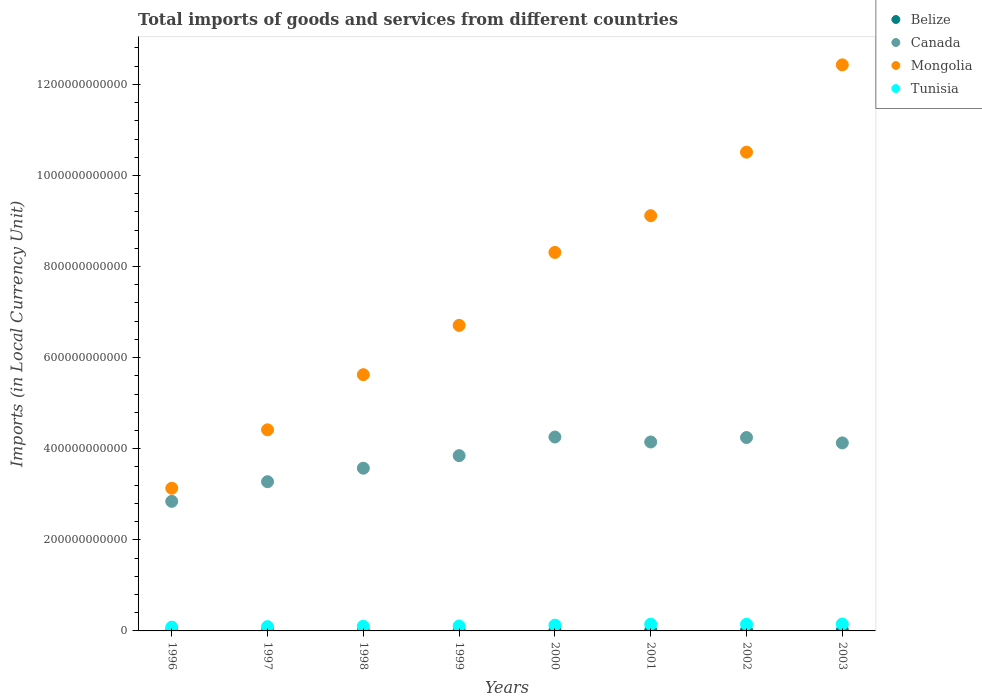Is the number of dotlines equal to the number of legend labels?
Ensure brevity in your answer.  Yes. What is the Amount of goods and services imports in Belize in 1999?
Provide a succinct answer. 9.87e+08. Across all years, what is the maximum Amount of goods and services imports in Mongolia?
Make the answer very short. 1.24e+12. Across all years, what is the minimum Amount of goods and services imports in Canada?
Provide a short and direct response. 2.84e+11. In which year was the Amount of goods and services imports in Tunisia minimum?
Your answer should be very brief. 1996. What is the total Amount of goods and services imports in Belize in the graph?
Give a very brief answer. 8.12e+09. What is the difference between the Amount of goods and services imports in Tunisia in 1999 and that in 2001?
Provide a short and direct response. -3.97e+09. What is the difference between the Amount of goods and services imports in Belize in 2003 and the Amount of goods and services imports in Canada in 1996?
Your response must be concise. -2.83e+11. What is the average Amount of goods and services imports in Belize per year?
Ensure brevity in your answer.  1.01e+09. In the year 2001, what is the difference between the Amount of goods and services imports in Mongolia and Amount of goods and services imports in Belize?
Make the answer very short. 9.10e+11. In how many years, is the Amount of goods and services imports in Tunisia greater than 320000000000 LCU?
Your answer should be very brief. 0. What is the ratio of the Amount of goods and services imports in Mongolia in 1998 to that in 2001?
Make the answer very short. 0.62. Is the Amount of goods and services imports in Belize in 1996 less than that in 1998?
Ensure brevity in your answer.  Yes. Is the difference between the Amount of goods and services imports in Mongolia in 2001 and 2002 greater than the difference between the Amount of goods and services imports in Belize in 2001 and 2002?
Offer a very short reply. No. What is the difference between the highest and the second highest Amount of goods and services imports in Mongolia?
Provide a succinct answer. 1.92e+11. What is the difference between the highest and the lowest Amount of goods and services imports in Belize?
Offer a terse response. 6.61e+08. In how many years, is the Amount of goods and services imports in Mongolia greater than the average Amount of goods and services imports in Mongolia taken over all years?
Offer a terse response. 4. Is it the case that in every year, the sum of the Amount of goods and services imports in Belize and Amount of goods and services imports in Mongolia  is greater than the Amount of goods and services imports in Tunisia?
Your response must be concise. Yes. Does the Amount of goods and services imports in Canada monotonically increase over the years?
Ensure brevity in your answer.  No. Is the Amount of goods and services imports in Tunisia strictly less than the Amount of goods and services imports in Canada over the years?
Provide a short and direct response. Yes. How many dotlines are there?
Your response must be concise. 4. How many years are there in the graph?
Give a very brief answer. 8. What is the difference between two consecutive major ticks on the Y-axis?
Make the answer very short. 2.00e+11. Does the graph contain grids?
Provide a short and direct response. No. How are the legend labels stacked?
Provide a short and direct response. Vertical. What is the title of the graph?
Provide a succinct answer. Total imports of goods and services from different countries. What is the label or title of the X-axis?
Offer a very short reply. Years. What is the label or title of the Y-axis?
Offer a very short reply. Imports (in Local Currency Unit). What is the Imports (in Local Currency Unit) in Belize in 1996?
Your answer should be compact. 6.45e+08. What is the Imports (in Local Currency Unit) of Canada in 1996?
Give a very brief answer. 2.84e+11. What is the Imports (in Local Currency Unit) in Mongolia in 1996?
Keep it short and to the point. 3.13e+11. What is the Imports (in Local Currency Unit) of Tunisia in 1996?
Make the answer very short. 8.32e+09. What is the Imports (in Local Currency Unit) of Belize in 1997?
Keep it short and to the point. 7.29e+08. What is the Imports (in Local Currency Unit) in Canada in 1997?
Provide a succinct answer. 3.28e+11. What is the Imports (in Local Currency Unit) in Mongolia in 1997?
Make the answer very short. 4.42e+11. What is the Imports (in Local Currency Unit) of Tunisia in 1997?
Your answer should be very brief. 9.50e+09. What is the Imports (in Local Currency Unit) in Belize in 1998?
Provide a short and direct response. 7.84e+08. What is the Imports (in Local Currency Unit) in Canada in 1998?
Provide a succinct answer. 3.57e+11. What is the Imports (in Local Currency Unit) in Mongolia in 1998?
Your response must be concise. 5.63e+11. What is the Imports (in Local Currency Unit) of Tunisia in 1998?
Make the answer very short. 1.03e+1. What is the Imports (in Local Currency Unit) in Belize in 1999?
Provide a short and direct response. 9.87e+08. What is the Imports (in Local Currency Unit) in Canada in 1999?
Your response must be concise. 3.85e+11. What is the Imports (in Local Currency Unit) of Mongolia in 1999?
Keep it short and to the point. 6.71e+11. What is the Imports (in Local Currency Unit) in Tunisia in 1999?
Make the answer very short. 1.09e+1. What is the Imports (in Local Currency Unit) in Belize in 2000?
Offer a terse response. 1.23e+09. What is the Imports (in Local Currency Unit) in Canada in 2000?
Make the answer very short. 4.26e+11. What is the Imports (in Local Currency Unit) in Mongolia in 2000?
Offer a very short reply. 8.31e+11. What is the Imports (in Local Currency Unit) of Tunisia in 2000?
Provide a succinct answer. 1.26e+1. What is the Imports (in Local Currency Unit) in Belize in 2001?
Keep it short and to the point. 1.20e+09. What is the Imports (in Local Currency Unit) of Canada in 2001?
Your answer should be very brief. 4.15e+11. What is the Imports (in Local Currency Unit) of Mongolia in 2001?
Offer a terse response. 9.12e+11. What is the Imports (in Local Currency Unit) in Tunisia in 2001?
Your answer should be very brief. 1.48e+1. What is the Imports (in Local Currency Unit) in Belize in 2002?
Provide a succinct answer. 1.23e+09. What is the Imports (in Local Currency Unit) of Canada in 2002?
Offer a very short reply. 4.25e+11. What is the Imports (in Local Currency Unit) of Mongolia in 2002?
Ensure brevity in your answer.  1.05e+12. What is the Imports (in Local Currency Unit) in Tunisia in 2002?
Offer a terse response. 1.47e+1. What is the Imports (in Local Currency Unit) in Belize in 2003?
Offer a terse response. 1.31e+09. What is the Imports (in Local Currency Unit) in Canada in 2003?
Give a very brief answer. 4.13e+11. What is the Imports (in Local Currency Unit) in Mongolia in 2003?
Your response must be concise. 1.24e+12. What is the Imports (in Local Currency Unit) in Tunisia in 2003?
Provide a short and direct response. 1.52e+1. Across all years, what is the maximum Imports (in Local Currency Unit) in Belize?
Provide a succinct answer. 1.31e+09. Across all years, what is the maximum Imports (in Local Currency Unit) in Canada?
Your answer should be compact. 4.26e+11. Across all years, what is the maximum Imports (in Local Currency Unit) in Mongolia?
Your answer should be very brief. 1.24e+12. Across all years, what is the maximum Imports (in Local Currency Unit) of Tunisia?
Give a very brief answer. 1.52e+1. Across all years, what is the minimum Imports (in Local Currency Unit) of Belize?
Ensure brevity in your answer.  6.45e+08. Across all years, what is the minimum Imports (in Local Currency Unit) in Canada?
Give a very brief answer. 2.84e+11. Across all years, what is the minimum Imports (in Local Currency Unit) in Mongolia?
Make the answer very short. 3.13e+11. Across all years, what is the minimum Imports (in Local Currency Unit) of Tunisia?
Offer a very short reply. 8.32e+09. What is the total Imports (in Local Currency Unit) of Belize in the graph?
Make the answer very short. 8.12e+09. What is the total Imports (in Local Currency Unit) of Canada in the graph?
Offer a terse response. 3.03e+12. What is the total Imports (in Local Currency Unit) of Mongolia in the graph?
Your response must be concise. 6.02e+12. What is the total Imports (in Local Currency Unit) of Tunisia in the graph?
Make the answer very short. 9.63e+1. What is the difference between the Imports (in Local Currency Unit) in Belize in 1996 and that in 1997?
Make the answer very short. -8.42e+07. What is the difference between the Imports (in Local Currency Unit) in Canada in 1996 and that in 1997?
Keep it short and to the point. -4.31e+1. What is the difference between the Imports (in Local Currency Unit) of Mongolia in 1996 and that in 1997?
Give a very brief answer. -1.28e+11. What is the difference between the Imports (in Local Currency Unit) of Tunisia in 1996 and that in 1997?
Provide a short and direct response. -1.18e+09. What is the difference between the Imports (in Local Currency Unit) of Belize in 1996 and that in 1998?
Keep it short and to the point. -1.40e+08. What is the difference between the Imports (in Local Currency Unit) of Canada in 1996 and that in 1998?
Make the answer very short. -7.28e+1. What is the difference between the Imports (in Local Currency Unit) of Mongolia in 1996 and that in 1998?
Give a very brief answer. -2.49e+11. What is the difference between the Imports (in Local Currency Unit) in Tunisia in 1996 and that in 1998?
Your answer should be very brief. -1.98e+09. What is the difference between the Imports (in Local Currency Unit) in Belize in 1996 and that in 1999?
Give a very brief answer. -3.42e+08. What is the difference between the Imports (in Local Currency Unit) of Canada in 1996 and that in 1999?
Your response must be concise. -1.00e+11. What is the difference between the Imports (in Local Currency Unit) of Mongolia in 1996 and that in 1999?
Offer a terse response. -3.58e+11. What is the difference between the Imports (in Local Currency Unit) of Tunisia in 1996 and that in 1999?
Keep it short and to the point. -2.55e+09. What is the difference between the Imports (in Local Currency Unit) of Belize in 1996 and that in 2000?
Give a very brief answer. -5.81e+08. What is the difference between the Imports (in Local Currency Unit) in Canada in 1996 and that in 2000?
Give a very brief answer. -1.41e+11. What is the difference between the Imports (in Local Currency Unit) in Mongolia in 1996 and that in 2000?
Make the answer very short. -5.18e+11. What is the difference between the Imports (in Local Currency Unit) in Tunisia in 1996 and that in 2000?
Your answer should be compact. -4.31e+09. What is the difference between the Imports (in Local Currency Unit) in Belize in 1996 and that in 2001?
Your response must be concise. -5.60e+08. What is the difference between the Imports (in Local Currency Unit) in Canada in 1996 and that in 2001?
Provide a succinct answer. -1.30e+11. What is the difference between the Imports (in Local Currency Unit) in Mongolia in 1996 and that in 2001?
Offer a terse response. -5.98e+11. What is the difference between the Imports (in Local Currency Unit) in Tunisia in 1996 and that in 2001?
Ensure brevity in your answer.  -6.52e+09. What is the difference between the Imports (in Local Currency Unit) in Belize in 1996 and that in 2002?
Make the answer very short. -5.89e+08. What is the difference between the Imports (in Local Currency Unit) in Canada in 1996 and that in 2002?
Give a very brief answer. -1.40e+11. What is the difference between the Imports (in Local Currency Unit) in Mongolia in 1996 and that in 2002?
Provide a short and direct response. -7.38e+11. What is the difference between the Imports (in Local Currency Unit) in Tunisia in 1996 and that in 2002?
Your response must be concise. -6.34e+09. What is the difference between the Imports (in Local Currency Unit) in Belize in 1996 and that in 2003?
Make the answer very short. -6.61e+08. What is the difference between the Imports (in Local Currency Unit) of Canada in 1996 and that in 2003?
Offer a terse response. -1.28e+11. What is the difference between the Imports (in Local Currency Unit) in Mongolia in 1996 and that in 2003?
Keep it short and to the point. -9.30e+11. What is the difference between the Imports (in Local Currency Unit) in Tunisia in 1996 and that in 2003?
Your answer should be compact. -6.86e+09. What is the difference between the Imports (in Local Currency Unit) of Belize in 1997 and that in 1998?
Offer a terse response. -5.55e+07. What is the difference between the Imports (in Local Currency Unit) of Canada in 1997 and that in 1998?
Make the answer very short. -2.96e+1. What is the difference between the Imports (in Local Currency Unit) in Mongolia in 1997 and that in 1998?
Give a very brief answer. -1.21e+11. What is the difference between the Imports (in Local Currency Unit) of Tunisia in 1997 and that in 1998?
Offer a terse response. -7.98e+08. What is the difference between the Imports (in Local Currency Unit) in Belize in 1997 and that in 1999?
Offer a terse response. -2.58e+08. What is the difference between the Imports (in Local Currency Unit) in Canada in 1997 and that in 1999?
Provide a succinct answer. -5.73e+1. What is the difference between the Imports (in Local Currency Unit) in Mongolia in 1997 and that in 1999?
Your response must be concise. -2.29e+11. What is the difference between the Imports (in Local Currency Unit) of Tunisia in 1997 and that in 1999?
Make the answer very short. -1.37e+09. What is the difference between the Imports (in Local Currency Unit) of Belize in 1997 and that in 2000?
Offer a terse response. -4.97e+08. What is the difference between the Imports (in Local Currency Unit) of Canada in 1997 and that in 2000?
Provide a short and direct response. -9.82e+1. What is the difference between the Imports (in Local Currency Unit) of Mongolia in 1997 and that in 2000?
Keep it short and to the point. -3.90e+11. What is the difference between the Imports (in Local Currency Unit) of Tunisia in 1997 and that in 2000?
Your answer should be compact. -3.13e+09. What is the difference between the Imports (in Local Currency Unit) in Belize in 1997 and that in 2001?
Your response must be concise. -4.76e+08. What is the difference between the Imports (in Local Currency Unit) in Canada in 1997 and that in 2001?
Offer a very short reply. -8.72e+1. What is the difference between the Imports (in Local Currency Unit) of Mongolia in 1997 and that in 2001?
Ensure brevity in your answer.  -4.70e+11. What is the difference between the Imports (in Local Currency Unit) in Tunisia in 1997 and that in 2001?
Your answer should be compact. -5.34e+09. What is the difference between the Imports (in Local Currency Unit) of Belize in 1997 and that in 2002?
Make the answer very short. -5.04e+08. What is the difference between the Imports (in Local Currency Unit) in Canada in 1997 and that in 2002?
Ensure brevity in your answer.  -9.70e+1. What is the difference between the Imports (in Local Currency Unit) of Mongolia in 1997 and that in 2002?
Ensure brevity in your answer.  -6.10e+11. What is the difference between the Imports (in Local Currency Unit) in Tunisia in 1997 and that in 2002?
Provide a short and direct response. -5.16e+09. What is the difference between the Imports (in Local Currency Unit) of Belize in 1997 and that in 2003?
Your response must be concise. -5.77e+08. What is the difference between the Imports (in Local Currency Unit) of Canada in 1997 and that in 2003?
Make the answer very short. -8.52e+1. What is the difference between the Imports (in Local Currency Unit) of Mongolia in 1997 and that in 2003?
Offer a very short reply. -8.01e+11. What is the difference between the Imports (in Local Currency Unit) of Tunisia in 1997 and that in 2003?
Make the answer very short. -5.68e+09. What is the difference between the Imports (in Local Currency Unit) in Belize in 1998 and that in 1999?
Offer a terse response. -2.03e+08. What is the difference between the Imports (in Local Currency Unit) in Canada in 1998 and that in 1999?
Offer a very short reply. -2.76e+1. What is the difference between the Imports (in Local Currency Unit) of Mongolia in 1998 and that in 1999?
Provide a succinct answer. -1.08e+11. What is the difference between the Imports (in Local Currency Unit) of Tunisia in 1998 and that in 1999?
Ensure brevity in your answer.  -5.73e+08. What is the difference between the Imports (in Local Currency Unit) of Belize in 1998 and that in 2000?
Provide a succinct answer. -4.42e+08. What is the difference between the Imports (in Local Currency Unit) of Canada in 1998 and that in 2000?
Ensure brevity in your answer.  -6.85e+1. What is the difference between the Imports (in Local Currency Unit) of Mongolia in 1998 and that in 2000?
Ensure brevity in your answer.  -2.68e+11. What is the difference between the Imports (in Local Currency Unit) in Tunisia in 1998 and that in 2000?
Your answer should be very brief. -2.34e+09. What is the difference between the Imports (in Local Currency Unit) of Belize in 1998 and that in 2001?
Your answer should be very brief. -4.20e+08. What is the difference between the Imports (in Local Currency Unit) of Canada in 1998 and that in 2001?
Your response must be concise. -5.76e+1. What is the difference between the Imports (in Local Currency Unit) of Mongolia in 1998 and that in 2001?
Offer a very short reply. -3.49e+11. What is the difference between the Imports (in Local Currency Unit) in Tunisia in 1998 and that in 2001?
Provide a short and direct response. -4.54e+09. What is the difference between the Imports (in Local Currency Unit) in Belize in 1998 and that in 2002?
Provide a short and direct response. -4.49e+08. What is the difference between the Imports (in Local Currency Unit) in Canada in 1998 and that in 2002?
Offer a terse response. -6.74e+1. What is the difference between the Imports (in Local Currency Unit) of Mongolia in 1998 and that in 2002?
Keep it short and to the point. -4.89e+11. What is the difference between the Imports (in Local Currency Unit) of Tunisia in 1998 and that in 2002?
Your response must be concise. -4.37e+09. What is the difference between the Imports (in Local Currency Unit) in Belize in 1998 and that in 2003?
Keep it short and to the point. -5.22e+08. What is the difference between the Imports (in Local Currency Unit) in Canada in 1998 and that in 2003?
Offer a very short reply. -5.56e+1. What is the difference between the Imports (in Local Currency Unit) of Mongolia in 1998 and that in 2003?
Keep it short and to the point. -6.80e+11. What is the difference between the Imports (in Local Currency Unit) of Tunisia in 1998 and that in 2003?
Offer a very short reply. -4.88e+09. What is the difference between the Imports (in Local Currency Unit) in Belize in 1999 and that in 2000?
Ensure brevity in your answer.  -2.39e+08. What is the difference between the Imports (in Local Currency Unit) of Canada in 1999 and that in 2000?
Your response must be concise. -4.09e+1. What is the difference between the Imports (in Local Currency Unit) in Mongolia in 1999 and that in 2000?
Your response must be concise. -1.60e+11. What is the difference between the Imports (in Local Currency Unit) of Tunisia in 1999 and that in 2000?
Keep it short and to the point. -1.76e+09. What is the difference between the Imports (in Local Currency Unit) of Belize in 1999 and that in 2001?
Offer a very short reply. -2.18e+08. What is the difference between the Imports (in Local Currency Unit) in Canada in 1999 and that in 2001?
Provide a succinct answer. -2.99e+1. What is the difference between the Imports (in Local Currency Unit) in Mongolia in 1999 and that in 2001?
Make the answer very short. -2.41e+11. What is the difference between the Imports (in Local Currency Unit) in Tunisia in 1999 and that in 2001?
Provide a succinct answer. -3.97e+09. What is the difference between the Imports (in Local Currency Unit) in Belize in 1999 and that in 2002?
Keep it short and to the point. -2.46e+08. What is the difference between the Imports (in Local Currency Unit) in Canada in 1999 and that in 2002?
Your response must be concise. -3.97e+1. What is the difference between the Imports (in Local Currency Unit) in Mongolia in 1999 and that in 2002?
Your answer should be compact. -3.80e+11. What is the difference between the Imports (in Local Currency Unit) in Tunisia in 1999 and that in 2002?
Keep it short and to the point. -3.79e+09. What is the difference between the Imports (in Local Currency Unit) in Belize in 1999 and that in 2003?
Your response must be concise. -3.19e+08. What is the difference between the Imports (in Local Currency Unit) of Canada in 1999 and that in 2003?
Make the answer very short. -2.79e+1. What is the difference between the Imports (in Local Currency Unit) in Mongolia in 1999 and that in 2003?
Your response must be concise. -5.72e+11. What is the difference between the Imports (in Local Currency Unit) in Tunisia in 1999 and that in 2003?
Give a very brief answer. -4.31e+09. What is the difference between the Imports (in Local Currency Unit) of Belize in 2000 and that in 2001?
Offer a very short reply. 2.11e+07. What is the difference between the Imports (in Local Currency Unit) in Canada in 2000 and that in 2001?
Offer a terse response. 1.09e+1. What is the difference between the Imports (in Local Currency Unit) of Mongolia in 2000 and that in 2001?
Your response must be concise. -8.07e+1. What is the difference between the Imports (in Local Currency Unit) of Tunisia in 2000 and that in 2001?
Ensure brevity in your answer.  -2.21e+09. What is the difference between the Imports (in Local Currency Unit) in Belize in 2000 and that in 2002?
Give a very brief answer. -7.40e+06. What is the difference between the Imports (in Local Currency Unit) in Canada in 2000 and that in 2002?
Provide a succinct answer. 1.13e+09. What is the difference between the Imports (in Local Currency Unit) in Mongolia in 2000 and that in 2002?
Provide a succinct answer. -2.20e+11. What is the difference between the Imports (in Local Currency Unit) of Tunisia in 2000 and that in 2002?
Give a very brief answer. -2.03e+09. What is the difference between the Imports (in Local Currency Unit) in Belize in 2000 and that in 2003?
Give a very brief answer. -8.00e+07. What is the difference between the Imports (in Local Currency Unit) of Canada in 2000 and that in 2003?
Provide a short and direct response. 1.29e+1. What is the difference between the Imports (in Local Currency Unit) in Mongolia in 2000 and that in 2003?
Keep it short and to the point. -4.12e+11. What is the difference between the Imports (in Local Currency Unit) of Tunisia in 2000 and that in 2003?
Provide a succinct answer. -2.55e+09. What is the difference between the Imports (in Local Currency Unit) of Belize in 2001 and that in 2002?
Provide a short and direct response. -2.85e+07. What is the difference between the Imports (in Local Currency Unit) in Canada in 2001 and that in 2002?
Your response must be concise. -9.81e+09. What is the difference between the Imports (in Local Currency Unit) of Mongolia in 2001 and that in 2002?
Provide a succinct answer. -1.39e+11. What is the difference between the Imports (in Local Currency Unit) in Tunisia in 2001 and that in 2002?
Give a very brief answer. 1.77e+08. What is the difference between the Imports (in Local Currency Unit) in Belize in 2001 and that in 2003?
Provide a succinct answer. -1.01e+08. What is the difference between the Imports (in Local Currency Unit) of Canada in 2001 and that in 2003?
Give a very brief answer. 2.00e+09. What is the difference between the Imports (in Local Currency Unit) of Mongolia in 2001 and that in 2003?
Provide a short and direct response. -3.31e+11. What is the difference between the Imports (in Local Currency Unit) in Tunisia in 2001 and that in 2003?
Give a very brief answer. -3.41e+08. What is the difference between the Imports (in Local Currency Unit) in Belize in 2002 and that in 2003?
Offer a terse response. -7.26e+07. What is the difference between the Imports (in Local Currency Unit) in Canada in 2002 and that in 2003?
Your response must be concise. 1.18e+1. What is the difference between the Imports (in Local Currency Unit) of Mongolia in 2002 and that in 2003?
Offer a very short reply. -1.92e+11. What is the difference between the Imports (in Local Currency Unit) in Tunisia in 2002 and that in 2003?
Offer a terse response. -5.18e+08. What is the difference between the Imports (in Local Currency Unit) in Belize in 1996 and the Imports (in Local Currency Unit) in Canada in 1997?
Offer a terse response. -3.27e+11. What is the difference between the Imports (in Local Currency Unit) in Belize in 1996 and the Imports (in Local Currency Unit) in Mongolia in 1997?
Make the answer very short. -4.41e+11. What is the difference between the Imports (in Local Currency Unit) of Belize in 1996 and the Imports (in Local Currency Unit) of Tunisia in 1997?
Ensure brevity in your answer.  -8.85e+09. What is the difference between the Imports (in Local Currency Unit) in Canada in 1996 and the Imports (in Local Currency Unit) in Mongolia in 1997?
Your answer should be compact. -1.57e+11. What is the difference between the Imports (in Local Currency Unit) in Canada in 1996 and the Imports (in Local Currency Unit) in Tunisia in 1997?
Your answer should be very brief. 2.75e+11. What is the difference between the Imports (in Local Currency Unit) in Mongolia in 1996 and the Imports (in Local Currency Unit) in Tunisia in 1997?
Ensure brevity in your answer.  3.04e+11. What is the difference between the Imports (in Local Currency Unit) in Belize in 1996 and the Imports (in Local Currency Unit) in Canada in 1998?
Your answer should be very brief. -3.57e+11. What is the difference between the Imports (in Local Currency Unit) in Belize in 1996 and the Imports (in Local Currency Unit) in Mongolia in 1998?
Ensure brevity in your answer.  -5.62e+11. What is the difference between the Imports (in Local Currency Unit) of Belize in 1996 and the Imports (in Local Currency Unit) of Tunisia in 1998?
Provide a succinct answer. -9.65e+09. What is the difference between the Imports (in Local Currency Unit) of Canada in 1996 and the Imports (in Local Currency Unit) of Mongolia in 1998?
Your answer should be very brief. -2.78e+11. What is the difference between the Imports (in Local Currency Unit) in Canada in 1996 and the Imports (in Local Currency Unit) in Tunisia in 1998?
Your answer should be compact. 2.74e+11. What is the difference between the Imports (in Local Currency Unit) of Mongolia in 1996 and the Imports (in Local Currency Unit) of Tunisia in 1998?
Provide a short and direct response. 3.03e+11. What is the difference between the Imports (in Local Currency Unit) of Belize in 1996 and the Imports (in Local Currency Unit) of Canada in 1999?
Offer a terse response. -3.84e+11. What is the difference between the Imports (in Local Currency Unit) of Belize in 1996 and the Imports (in Local Currency Unit) of Mongolia in 1999?
Provide a short and direct response. -6.70e+11. What is the difference between the Imports (in Local Currency Unit) of Belize in 1996 and the Imports (in Local Currency Unit) of Tunisia in 1999?
Your answer should be very brief. -1.02e+1. What is the difference between the Imports (in Local Currency Unit) of Canada in 1996 and the Imports (in Local Currency Unit) of Mongolia in 1999?
Make the answer very short. -3.86e+11. What is the difference between the Imports (in Local Currency Unit) of Canada in 1996 and the Imports (in Local Currency Unit) of Tunisia in 1999?
Your response must be concise. 2.74e+11. What is the difference between the Imports (in Local Currency Unit) in Mongolia in 1996 and the Imports (in Local Currency Unit) in Tunisia in 1999?
Provide a succinct answer. 3.02e+11. What is the difference between the Imports (in Local Currency Unit) of Belize in 1996 and the Imports (in Local Currency Unit) of Canada in 2000?
Give a very brief answer. -4.25e+11. What is the difference between the Imports (in Local Currency Unit) of Belize in 1996 and the Imports (in Local Currency Unit) of Mongolia in 2000?
Make the answer very short. -8.30e+11. What is the difference between the Imports (in Local Currency Unit) of Belize in 1996 and the Imports (in Local Currency Unit) of Tunisia in 2000?
Your answer should be compact. -1.20e+1. What is the difference between the Imports (in Local Currency Unit) in Canada in 1996 and the Imports (in Local Currency Unit) in Mongolia in 2000?
Your answer should be very brief. -5.47e+11. What is the difference between the Imports (in Local Currency Unit) in Canada in 1996 and the Imports (in Local Currency Unit) in Tunisia in 2000?
Provide a succinct answer. 2.72e+11. What is the difference between the Imports (in Local Currency Unit) in Mongolia in 1996 and the Imports (in Local Currency Unit) in Tunisia in 2000?
Make the answer very short. 3.01e+11. What is the difference between the Imports (in Local Currency Unit) in Belize in 1996 and the Imports (in Local Currency Unit) in Canada in 2001?
Make the answer very short. -4.14e+11. What is the difference between the Imports (in Local Currency Unit) of Belize in 1996 and the Imports (in Local Currency Unit) of Mongolia in 2001?
Offer a terse response. -9.11e+11. What is the difference between the Imports (in Local Currency Unit) of Belize in 1996 and the Imports (in Local Currency Unit) of Tunisia in 2001?
Your answer should be compact. -1.42e+1. What is the difference between the Imports (in Local Currency Unit) of Canada in 1996 and the Imports (in Local Currency Unit) of Mongolia in 2001?
Keep it short and to the point. -6.27e+11. What is the difference between the Imports (in Local Currency Unit) of Canada in 1996 and the Imports (in Local Currency Unit) of Tunisia in 2001?
Your response must be concise. 2.70e+11. What is the difference between the Imports (in Local Currency Unit) in Mongolia in 1996 and the Imports (in Local Currency Unit) in Tunisia in 2001?
Provide a succinct answer. 2.98e+11. What is the difference between the Imports (in Local Currency Unit) of Belize in 1996 and the Imports (in Local Currency Unit) of Canada in 2002?
Keep it short and to the point. -4.24e+11. What is the difference between the Imports (in Local Currency Unit) in Belize in 1996 and the Imports (in Local Currency Unit) in Mongolia in 2002?
Your response must be concise. -1.05e+12. What is the difference between the Imports (in Local Currency Unit) in Belize in 1996 and the Imports (in Local Currency Unit) in Tunisia in 2002?
Keep it short and to the point. -1.40e+1. What is the difference between the Imports (in Local Currency Unit) in Canada in 1996 and the Imports (in Local Currency Unit) in Mongolia in 2002?
Your answer should be compact. -7.67e+11. What is the difference between the Imports (in Local Currency Unit) of Canada in 1996 and the Imports (in Local Currency Unit) of Tunisia in 2002?
Make the answer very short. 2.70e+11. What is the difference between the Imports (in Local Currency Unit) of Mongolia in 1996 and the Imports (in Local Currency Unit) of Tunisia in 2002?
Your answer should be compact. 2.99e+11. What is the difference between the Imports (in Local Currency Unit) of Belize in 1996 and the Imports (in Local Currency Unit) of Canada in 2003?
Your answer should be very brief. -4.12e+11. What is the difference between the Imports (in Local Currency Unit) of Belize in 1996 and the Imports (in Local Currency Unit) of Mongolia in 2003?
Provide a succinct answer. -1.24e+12. What is the difference between the Imports (in Local Currency Unit) of Belize in 1996 and the Imports (in Local Currency Unit) of Tunisia in 2003?
Your response must be concise. -1.45e+1. What is the difference between the Imports (in Local Currency Unit) of Canada in 1996 and the Imports (in Local Currency Unit) of Mongolia in 2003?
Your response must be concise. -9.58e+11. What is the difference between the Imports (in Local Currency Unit) in Canada in 1996 and the Imports (in Local Currency Unit) in Tunisia in 2003?
Give a very brief answer. 2.69e+11. What is the difference between the Imports (in Local Currency Unit) in Mongolia in 1996 and the Imports (in Local Currency Unit) in Tunisia in 2003?
Offer a terse response. 2.98e+11. What is the difference between the Imports (in Local Currency Unit) of Belize in 1997 and the Imports (in Local Currency Unit) of Canada in 1998?
Make the answer very short. -3.57e+11. What is the difference between the Imports (in Local Currency Unit) of Belize in 1997 and the Imports (in Local Currency Unit) of Mongolia in 1998?
Make the answer very short. -5.62e+11. What is the difference between the Imports (in Local Currency Unit) in Belize in 1997 and the Imports (in Local Currency Unit) in Tunisia in 1998?
Provide a short and direct response. -9.56e+09. What is the difference between the Imports (in Local Currency Unit) of Canada in 1997 and the Imports (in Local Currency Unit) of Mongolia in 1998?
Provide a succinct answer. -2.35e+11. What is the difference between the Imports (in Local Currency Unit) in Canada in 1997 and the Imports (in Local Currency Unit) in Tunisia in 1998?
Your response must be concise. 3.17e+11. What is the difference between the Imports (in Local Currency Unit) in Mongolia in 1997 and the Imports (in Local Currency Unit) in Tunisia in 1998?
Your response must be concise. 4.31e+11. What is the difference between the Imports (in Local Currency Unit) of Belize in 1997 and the Imports (in Local Currency Unit) of Canada in 1999?
Your response must be concise. -3.84e+11. What is the difference between the Imports (in Local Currency Unit) in Belize in 1997 and the Imports (in Local Currency Unit) in Mongolia in 1999?
Provide a succinct answer. -6.70e+11. What is the difference between the Imports (in Local Currency Unit) of Belize in 1997 and the Imports (in Local Currency Unit) of Tunisia in 1999?
Offer a very short reply. -1.01e+1. What is the difference between the Imports (in Local Currency Unit) in Canada in 1997 and the Imports (in Local Currency Unit) in Mongolia in 1999?
Provide a short and direct response. -3.43e+11. What is the difference between the Imports (in Local Currency Unit) in Canada in 1997 and the Imports (in Local Currency Unit) in Tunisia in 1999?
Your answer should be compact. 3.17e+11. What is the difference between the Imports (in Local Currency Unit) in Mongolia in 1997 and the Imports (in Local Currency Unit) in Tunisia in 1999?
Provide a succinct answer. 4.31e+11. What is the difference between the Imports (in Local Currency Unit) of Belize in 1997 and the Imports (in Local Currency Unit) of Canada in 2000?
Provide a succinct answer. -4.25e+11. What is the difference between the Imports (in Local Currency Unit) in Belize in 1997 and the Imports (in Local Currency Unit) in Mongolia in 2000?
Keep it short and to the point. -8.30e+11. What is the difference between the Imports (in Local Currency Unit) of Belize in 1997 and the Imports (in Local Currency Unit) of Tunisia in 2000?
Ensure brevity in your answer.  -1.19e+1. What is the difference between the Imports (in Local Currency Unit) in Canada in 1997 and the Imports (in Local Currency Unit) in Mongolia in 2000?
Provide a succinct answer. -5.03e+11. What is the difference between the Imports (in Local Currency Unit) of Canada in 1997 and the Imports (in Local Currency Unit) of Tunisia in 2000?
Ensure brevity in your answer.  3.15e+11. What is the difference between the Imports (in Local Currency Unit) in Mongolia in 1997 and the Imports (in Local Currency Unit) in Tunisia in 2000?
Your answer should be very brief. 4.29e+11. What is the difference between the Imports (in Local Currency Unit) of Belize in 1997 and the Imports (in Local Currency Unit) of Canada in 2001?
Your answer should be very brief. -4.14e+11. What is the difference between the Imports (in Local Currency Unit) of Belize in 1997 and the Imports (in Local Currency Unit) of Mongolia in 2001?
Offer a very short reply. -9.11e+11. What is the difference between the Imports (in Local Currency Unit) in Belize in 1997 and the Imports (in Local Currency Unit) in Tunisia in 2001?
Your answer should be very brief. -1.41e+1. What is the difference between the Imports (in Local Currency Unit) of Canada in 1997 and the Imports (in Local Currency Unit) of Mongolia in 2001?
Your answer should be very brief. -5.84e+11. What is the difference between the Imports (in Local Currency Unit) of Canada in 1997 and the Imports (in Local Currency Unit) of Tunisia in 2001?
Provide a succinct answer. 3.13e+11. What is the difference between the Imports (in Local Currency Unit) in Mongolia in 1997 and the Imports (in Local Currency Unit) in Tunisia in 2001?
Give a very brief answer. 4.27e+11. What is the difference between the Imports (in Local Currency Unit) in Belize in 1997 and the Imports (in Local Currency Unit) in Canada in 2002?
Your answer should be very brief. -4.24e+11. What is the difference between the Imports (in Local Currency Unit) in Belize in 1997 and the Imports (in Local Currency Unit) in Mongolia in 2002?
Keep it short and to the point. -1.05e+12. What is the difference between the Imports (in Local Currency Unit) in Belize in 1997 and the Imports (in Local Currency Unit) in Tunisia in 2002?
Your answer should be very brief. -1.39e+1. What is the difference between the Imports (in Local Currency Unit) in Canada in 1997 and the Imports (in Local Currency Unit) in Mongolia in 2002?
Provide a short and direct response. -7.24e+11. What is the difference between the Imports (in Local Currency Unit) in Canada in 1997 and the Imports (in Local Currency Unit) in Tunisia in 2002?
Give a very brief answer. 3.13e+11. What is the difference between the Imports (in Local Currency Unit) of Mongolia in 1997 and the Imports (in Local Currency Unit) of Tunisia in 2002?
Provide a succinct answer. 4.27e+11. What is the difference between the Imports (in Local Currency Unit) of Belize in 1997 and the Imports (in Local Currency Unit) of Canada in 2003?
Offer a terse response. -4.12e+11. What is the difference between the Imports (in Local Currency Unit) of Belize in 1997 and the Imports (in Local Currency Unit) of Mongolia in 2003?
Offer a terse response. -1.24e+12. What is the difference between the Imports (in Local Currency Unit) of Belize in 1997 and the Imports (in Local Currency Unit) of Tunisia in 2003?
Provide a short and direct response. -1.44e+1. What is the difference between the Imports (in Local Currency Unit) of Canada in 1997 and the Imports (in Local Currency Unit) of Mongolia in 2003?
Offer a terse response. -9.15e+11. What is the difference between the Imports (in Local Currency Unit) in Canada in 1997 and the Imports (in Local Currency Unit) in Tunisia in 2003?
Keep it short and to the point. 3.12e+11. What is the difference between the Imports (in Local Currency Unit) in Mongolia in 1997 and the Imports (in Local Currency Unit) in Tunisia in 2003?
Provide a succinct answer. 4.26e+11. What is the difference between the Imports (in Local Currency Unit) in Belize in 1998 and the Imports (in Local Currency Unit) in Canada in 1999?
Provide a succinct answer. -3.84e+11. What is the difference between the Imports (in Local Currency Unit) of Belize in 1998 and the Imports (in Local Currency Unit) of Mongolia in 1999?
Your answer should be very brief. -6.70e+11. What is the difference between the Imports (in Local Currency Unit) in Belize in 1998 and the Imports (in Local Currency Unit) in Tunisia in 1999?
Your answer should be compact. -1.01e+1. What is the difference between the Imports (in Local Currency Unit) in Canada in 1998 and the Imports (in Local Currency Unit) in Mongolia in 1999?
Ensure brevity in your answer.  -3.14e+11. What is the difference between the Imports (in Local Currency Unit) of Canada in 1998 and the Imports (in Local Currency Unit) of Tunisia in 1999?
Offer a terse response. 3.46e+11. What is the difference between the Imports (in Local Currency Unit) of Mongolia in 1998 and the Imports (in Local Currency Unit) of Tunisia in 1999?
Provide a succinct answer. 5.52e+11. What is the difference between the Imports (in Local Currency Unit) of Belize in 1998 and the Imports (in Local Currency Unit) of Canada in 2000?
Ensure brevity in your answer.  -4.25e+11. What is the difference between the Imports (in Local Currency Unit) in Belize in 1998 and the Imports (in Local Currency Unit) in Mongolia in 2000?
Offer a very short reply. -8.30e+11. What is the difference between the Imports (in Local Currency Unit) of Belize in 1998 and the Imports (in Local Currency Unit) of Tunisia in 2000?
Provide a succinct answer. -1.18e+1. What is the difference between the Imports (in Local Currency Unit) in Canada in 1998 and the Imports (in Local Currency Unit) in Mongolia in 2000?
Your answer should be very brief. -4.74e+11. What is the difference between the Imports (in Local Currency Unit) in Canada in 1998 and the Imports (in Local Currency Unit) in Tunisia in 2000?
Your answer should be very brief. 3.45e+11. What is the difference between the Imports (in Local Currency Unit) in Mongolia in 1998 and the Imports (in Local Currency Unit) in Tunisia in 2000?
Offer a very short reply. 5.50e+11. What is the difference between the Imports (in Local Currency Unit) of Belize in 1998 and the Imports (in Local Currency Unit) of Canada in 2001?
Ensure brevity in your answer.  -4.14e+11. What is the difference between the Imports (in Local Currency Unit) in Belize in 1998 and the Imports (in Local Currency Unit) in Mongolia in 2001?
Make the answer very short. -9.11e+11. What is the difference between the Imports (in Local Currency Unit) in Belize in 1998 and the Imports (in Local Currency Unit) in Tunisia in 2001?
Offer a terse response. -1.41e+1. What is the difference between the Imports (in Local Currency Unit) of Canada in 1998 and the Imports (in Local Currency Unit) of Mongolia in 2001?
Your answer should be very brief. -5.54e+11. What is the difference between the Imports (in Local Currency Unit) of Canada in 1998 and the Imports (in Local Currency Unit) of Tunisia in 2001?
Your response must be concise. 3.42e+11. What is the difference between the Imports (in Local Currency Unit) of Mongolia in 1998 and the Imports (in Local Currency Unit) of Tunisia in 2001?
Offer a terse response. 5.48e+11. What is the difference between the Imports (in Local Currency Unit) of Belize in 1998 and the Imports (in Local Currency Unit) of Canada in 2002?
Ensure brevity in your answer.  -4.24e+11. What is the difference between the Imports (in Local Currency Unit) of Belize in 1998 and the Imports (in Local Currency Unit) of Mongolia in 2002?
Your answer should be very brief. -1.05e+12. What is the difference between the Imports (in Local Currency Unit) of Belize in 1998 and the Imports (in Local Currency Unit) of Tunisia in 2002?
Your answer should be compact. -1.39e+1. What is the difference between the Imports (in Local Currency Unit) of Canada in 1998 and the Imports (in Local Currency Unit) of Mongolia in 2002?
Provide a succinct answer. -6.94e+11. What is the difference between the Imports (in Local Currency Unit) in Canada in 1998 and the Imports (in Local Currency Unit) in Tunisia in 2002?
Your answer should be compact. 3.43e+11. What is the difference between the Imports (in Local Currency Unit) of Mongolia in 1998 and the Imports (in Local Currency Unit) of Tunisia in 2002?
Give a very brief answer. 5.48e+11. What is the difference between the Imports (in Local Currency Unit) of Belize in 1998 and the Imports (in Local Currency Unit) of Canada in 2003?
Give a very brief answer. -4.12e+11. What is the difference between the Imports (in Local Currency Unit) in Belize in 1998 and the Imports (in Local Currency Unit) in Mongolia in 2003?
Your answer should be very brief. -1.24e+12. What is the difference between the Imports (in Local Currency Unit) in Belize in 1998 and the Imports (in Local Currency Unit) in Tunisia in 2003?
Ensure brevity in your answer.  -1.44e+1. What is the difference between the Imports (in Local Currency Unit) of Canada in 1998 and the Imports (in Local Currency Unit) of Mongolia in 2003?
Provide a succinct answer. -8.86e+11. What is the difference between the Imports (in Local Currency Unit) of Canada in 1998 and the Imports (in Local Currency Unit) of Tunisia in 2003?
Make the answer very short. 3.42e+11. What is the difference between the Imports (in Local Currency Unit) in Mongolia in 1998 and the Imports (in Local Currency Unit) in Tunisia in 2003?
Make the answer very short. 5.47e+11. What is the difference between the Imports (in Local Currency Unit) of Belize in 1999 and the Imports (in Local Currency Unit) of Canada in 2000?
Offer a very short reply. -4.25e+11. What is the difference between the Imports (in Local Currency Unit) in Belize in 1999 and the Imports (in Local Currency Unit) in Mongolia in 2000?
Make the answer very short. -8.30e+11. What is the difference between the Imports (in Local Currency Unit) of Belize in 1999 and the Imports (in Local Currency Unit) of Tunisia in 2000?
Keep it short and to the point. -1.16e+1. What is the difference between the Imports (in Local Currency Unit) of Canada in 1999 and the Imports (in Local Currency Unit) of Mongolia in 2000?
Ensure brevity in your answer.  -4.46e+11. What is the difference between the Imports (in Local Currency Unit) of Canada in 1999 and the Imports (in Local Currency Unit) of Tunisia in 2000?
Give a very brief answer. 3.72e+11. What is the difference between the Imports (in Local Currency Unit) in Mongolia in 1999 and the Imports (in Local Currency Unit) in Tunisia in 2000?
Offer a terse response. 6.58e+11. What is the difference between the Imports (in Local Currency Unit) of Belize in 1999 and the Imports (in Local Currency Unit) of Canada in 2001?
Give a very brief answer. -4.14e+11. What is the difference between the Imports (in Local Currency Unit) in Belize in 1999 and the Imports (in Local Currency Unit) in Mongolia in 2001?
Give a very brief answer. -9.11e+11. What is the difference between the Imports (in Local Currency Unit) of Belize in 1999 and the Imports (in Local Currency Unit) of Tunisia in 2001?
Provide a short and direct response. -1.38e+1. What is the difference between the Imports (in Local Currency Unit) in Canada in 1999 and the Imports (in Local Currency Unit) in Mongolia in 2001?
Keep it short and to the point. -5.27e+11. What is the difference between the Imports (in Local Currency Unit) of Canada in 1999 and the Imports (in Local Currency Unit) of Tunisia in 2001?
Your answer should be very brief. 3.70e+11. What is the difference between the Imports (in Local Currency Unit) of Mongolia in 1999 and the Imports (in Local Currency Unit) of Tunisia in 2001?
Your response must be concise. 6.56e+11. What is the difference between the Imports (in Local Currency Unit) of Belize in 1999 and the Imports (in Local Currency Unit) of Canada in 2002?
Your answer should be very brief. -4.24e+11. What is the difference between the Imports (in Local Currency Unit) in Belize in 1999 and the Imports (in Local Currency Unit) in Mongolia in 2002?
Offer a very short reply. -1.05e+12. What is the difference between the Imports (in Local Currency Unit) of Belize in 1999 and the Imports (in Local Currency Unit) of Tunisia in 2002?
Ensure brevity in your answer.  -1.37e+1. What is the difference between the Imports (in Local Currency Unit) in Canada in 1999 and the Imports (in Local Currency Unit) in Mongolia in 2002?
Your response must be concise. -6.66e+11. What is the difference between the Imports (in Local Currency Unit) of Canada in 1999 and the Imports (in Local Currency Unit) of Tunisia in 2002?
Offer a very short reply. 3.70e+11. What is the difference between the Imports (in Local Currency Unit) of Mongolia in 1999 and the Imports (in Local Currency Unit) of Tunisia in 2002?
Offer a very short reply. 6.56e+11. What is the difference between the Imports (in Local Currency Unit) of Belize in 1999 and the Imports (in Local Currency Unit) of Canada in 2003?
Your response must be concise. -4.12e+11. What is the difference between the Imports (in Local Currency Unit) in Belize in 1999 and the Imports (in Local Currency Unit) in Mongolia in 2003?
Keep it short and to the point. -1.24e+12. What is the difference between the Imports (in Local Currency Unit) of Belize in 1999 and the Imports (in Local Currency Unit) of Tunisia in 2003?
Provide a succinct answer. -1.42e+1. What is the difference between the Imports (in Local Currency Unit) in Canada in 1999 and the Imports (in Local Currency Unit) in Mongolia in 2003?
Ensure brevity in your answer.  -8.58e+11. What is the difference between the Imports (in Local Currency Unit) of Canada in 1999 and the Imports (in Local Currency Unit) of Tunisia in 2003?
Give a very brief answer. 3.70e+11. What is the difference between the Imports (in Local Currency Unit) of Mongolia in 1999 and the Imports (in Local Currency Unit) of Tunisia in 2003?
Your answer should be compact. 6.56e+11. What is the difference between the Imports (in Local Currency Unit) of Belize in 2000 and the Imports (in Local Currency Unit) of Canada in 2001?
Your response must be concise. -4.14e+11. What is the difference between the Imports (in Local Currency Unit) of Belize in 2000 and the Imports (in Local Currency Unit) of Mongolia in 2001?
Your answer should be compact. -9.10e+11. What is the difference between the Imports (in Local Currency Unit) in Belize in 2000 and the Imports (in Local Currency Unit) in Tunisia in 2001?
Provide a succinct answer. -1.36e+1. What is the difference between the Imports (in Local Currency Unit) in Canada in 2000 and the Imports (in Local Currency Unit) in Mongolia in 2001?
Provide a succinct answer. -4.86e+11. What is the difference between the Imports (in Local Currency Unit) of Canada in 2000 and the Imports (in Local Currency Unit) of Tunisia in 2001?
Your answer should be compact. 4.11e+11. What is the difference between the Imports (in Local Currency Unit) in Mongolia in 2000 and the Imports (in Local Currency Unit) in Tunisia in 2001?
Provide a short and direct response. 8.16e+11. What is the difference between the Imports (in Local Currency Unit) in Belize in 2000 and the Imports (in Local Currency Unit) in Canada in 2002?
Make the answer very short. -4.23e+11. What is the difference between the Imports (in Local Currency Unit) of Belize in 2000 and the Imports (in Local Currency Unit) of Mongolia in 2002?
Your answer should be very brief. -1.05e+12. What is the difference between the Imports (in Local Currency Unit) of Belize in 2000 and the Imports (in Local Currency Unit) of Tunisia in 2002?
Make the answer very short. -1.34e+1. What is the difference between the Imports (in Local Currency Unit) in Canada in 2000 and the Imports (in Local Currency Unit) in Mongolia in 2002?
Offer a very short reply. -6.25e+11. What is the difference between the Imports (in Local Currency Unit) of Canada in 2000 and the Imports (in Local Currency Unit) of Tunisia in 2002?
Provide a succinct answer. 4.11e+11. What is the difference between the Imports (in Local Currency Unit) of Mongolia in 2000 and the Imports (in Local Currency Unit) of Tunisia in 2002?
Provide a short and direct response. 8.16e+11. What is the difference between the Imports (in Local Currency Unit) of Belize in 2000 and the Imports (in Local Currency Unit) of Canada in 2003?
Ensure brevity in your answer.  -4.12e+11. What is the difference between the Imports (in Local Currency Unit) in Belize in 2000 and the Imports (in Local Currency Unit) in Mongolia in 2003?
Your response must be concise. -1.24e+12. What is the difference between the Imports (in Local Currency Unit) of Belize in 2000 and the Imports (in Local Currency Unit) of Tunisia in 2003?
Offer a terse response. -1.40e+1. What is the difference between the Imports (in Local Currency Unit) in Canada in 2000 and the Imports (in Local Currency Unit) in Mongolia in 2003?
Your answer should be compact. -8.17e+11. What is the difference between the Imports (in Local Currency Unit) in Canada in 2000 and the Imports (in Local Currency Unit) in Tunisia in 2003?
Keep it short and to the point. 4.11e+11. What is the difference between the Imports (in Local Currency Unit) of Mongolia in 2000 and the Imports (in Local Currency Unit) of Tunisia in 2003?
Your answer should be very brief. 8.16e+11. What is the difference between the Imports (in Local Currency Unit) of Belize in 2001 and the Imports (in Local Currency Unit) of Canada in 2002?
Ensure brevity in your answer.  -4.23e+11. What is the difference between the Imports (in Local Currency Unit) of Belize in 2001 and the Imports (in Local Currency Unit) of Mongolia in 2002?
Your answer should be very brief. -1.05e+12. What is the difference between the Imports (in Local Currency Unit) of Belize in 2001 and the Imports (in Local Currency Unit) of Tunisia in 2002?
Make the answer very short. -1.35e+1. What is the difference between the Imports (in Local Currency Unit) in Canada in 2001 and the Imports (in Local Currency Unit) in Mongolia in 2002?
Keep it short and to the point. -6.36e+11. What is the difference between the Imports (in Local Currency Unit) in Canada in 2001 and the Imports (in Local Currency Unit) in Tunisia in 2002?
Your answer should be compact. 4.00e+11. What is the difference between the Imports (in Local Currency Unit) in Mongolia in 2001 and the Imports (in Local Currency Unit) in Tunisia in 2002?
Give a very brief answer. 8.97e+11. What is the difference between the Imports (in Local Currency Unit) of Belize in 2001 and the Imports (in Local Currency Unit) of Canada in 2003?
Your answer should be compact. -4.12e+11. What is the difference between the Imports (in Local Currency Unit) of Belize in 2001 and the Imports (in Local Currency Unit) of Mongolia in 2003?
Ensure brevity in your answer.  -1.24e+12. What is the difference between the Imports (in Local Currency Unit) in Belize in 2001 and the Imports (in Local Currency Unit) in Tunisia in 2003?
Your response must be concise. -1.40e+1. What is the difference between the Imports (in Local Currency Unit) in Canada in 2001 and the Imports (in Local Currency Unit) in Mongolia in 2003?
Ensure brevity in your answer.  -8.28e+11. What is the difference between the Imports (in Local Currency Unit) of Canada in 2001 and the Imports (in Local Currency Unit) of Tunisia in 2003?
Your answer should be very brief. 4.00e+11. What is the difference between the Imports (in Local Currency Unit) of Mongolia in 2001 and the Imports (in Local Currency Unit) of Tunisia in 2003?
Ensure brevity in your answer.  8.97e+11. What is the difference between the Imports (in Local Currency Unit) in Belize in 2002 and the Imports (in Local Currency Unit) in Canada in 2003?
Offer a very short reply. -4.12e+11. What is the difference between the Imports (in Local Currency Unit) in Belize in 2002 and the Imports (in Local Currency Unit) in Mongolia in 2003?
Offer a terse response. -1.24e+12. What is the difference between the Imports (in Local Currency Unit) of Belize in 2002 and the Imports (in Local Currency Unit) of Tunisia in 2003?
Keep it short and to the point. -1.39e+1. What is the difference between the Imports (in Local Currency Unit) in Canada in 2002 and the Imports (in Local Currency Unit) in Mongolia in 2003?
Your answer should be very brief. -8.18e+11. What is the difference between the Imports (in Local Currency Unit) in Canada in 2002 and the Imports (in Local Currency Unit) in Tunisia in 2003?
Your answer should be very brief. 4.09e+11. What is the difference between the Imports (in Local Currency Unit) in Mongolia in 2002 and the Imports (in Local Currency Unit) in Tunisia in 2003?
Ensure brevity in your answer.  1.04e+12. What is the average Imports (in Local Currency Unit) of Belize per year?
Your response must be concise. 1.01e+09. What is the average Imports (in Local Currency Unit) of Canada per year?
Offer a very short reply. 3.79e+11. What is the average Imports (in Local Currency Unit) in Mongolia per year?
Offer a very short reply. 7.53e+11. What is the average Imports (in Local Currency Unit) in Tunisia per year?
Your answer should be very brief. 1.20e+1. In the year 1996, what is the difference between the Imports (in Local Currency Unit) of Belize and Imports (in Local Currency Unit) of Canada?
Offer a terse response. -2.84e+11. In the year 1996, what is the difference between the Imports (in Local Currency Unit) of Belize and Imports (in Local Currency Unit) of Mongolia?
Ensure brevity in your answer.  -3.13e+11. In the year 1996, what is the difference between the Imports (in Local Currency Unit) in Belize and Imports (in Local Currency Unit) in Tunisia?
Ensure brevity in your answer.  -7.67e+09. In the year 1996, what is the difference between the Imports (in Local Currency Unit) of Canada and Imports (in Local Currency Unit) of Mongolia?
Make the answer very short. -2.88e+1. In the year 1996, what is the difference between the Imports (in Local Currency Unit) in Canada and Imports (in Local Currency Unit) in Tunisia?
Offer a terse response. 2.76e+11. In the year 1996, what is the difference between the Imports (in Local Currency Unit) of Mongolia and Imports (in Local Currency Unit) of Tunisia?
Provide a short and direct response. 3.05e+11. In the year 1997, what is the difference between the Imports (in Local Currency Unit) in Belize and Imports (in Local Currency Unit) in Canada?
Your answer should be very brief. -3.27e+11. In the year 1997, what is the difference between the Imports (in Local Currency Unit) of Belize and Imports (in Local Currency Unit) of Mongolia?
Your response must be concise. -4.41e+11. In the year 1997, what is the difference between the Imports (in Local Currency Unit) of Belize and Imports (in Local Currency Unit) of Tunisia?
Your answer should be very brief. -8.77e+09. In the year 1997, what is the difference between the Imports (in Local Currency Unit) in Canada and Imports (in Local Currency Unit) in Mongolia?
Offer a very short reply. -1.14e+11. In the year 1997, what is the difference between the Imports (in Local Currency Unit) in Canada and Imports (in Local Currency Unit) in Tunisia?
Your response must be concise. 3.18e+11. In the year 1997, what is the difference between the Imports (in Local Currency Unit) in Mongolia and Imports (in Local Currency Unit) in Tunisia?
Your answer should be compact. 4.32e+11. In the year 1998, what is the difference between the Imports (in Local Currency Unit) of Belize and Imports (in Local Currency Unit) of Canada?
Offer a terse response. -3.56e+11. In the year 1998, what is the difference between the Imports (in Local Currency Unit) of Belize and Imports (in Local Currency Unit) of Mongolia?
Keep it short and to the point. -5.62e+11. In the year 1998, what is the difference between the Imports (in Local Currency Unit) in Belize and Imports (in Local Currency Unit) in Tunisia?
Your answer should be very brief. -9.51e+09. In the year 1998, what is the difference between the Imports (in Local Currency Unit) in Canada and Imports (in Local Currency Unit) in Mongolia?
Make the answer very short. -2.05e+11. In the year 1998, what is the difference between the Imports (in Local Currency Unit) of Canada and Imports (in Local Currency Unit) of Tunisia?
Ensure brevity in your answer.  3.47e+11. In the year 1998, what is the difference between the Imports (in Local Currency Unit) in Mongolia and Imports (in Local Currency Unit) in Tunisia?
Offer a terse response. 5.52e+11. In the year 1999, what is the difference between the Imports (in Local Currency Unit) of Belize and Imports (in Local Currency Unit) of Canada?
Provide a short and direct response. -3.84e+11. In the year 1999, what is the difference between the Imports (in Local Currency Unit) of Belize and Imports (in Local Currency Unit) of Mongolia?
Ensure brevity in your answer.  -6.70e+11. In the year 1999, what is the difference between the Imports (in Local Currency Unit) in Belize and Imports (in Local Currency Unit) in Tunisia?
Provide a short and direct response. -9.88e+09. In the year 1999, what is the difference between the Imports (in Local Currency Unit) of Canada and Imports (in Local Currency Unit) of Mongolia?
Make the answer very short. -2.86e+11. In the year 1999, what is the difference between the Imports (in Local Currency Unit) in Canada and Imports (in Local Currency Unit) in Tunisia?
Provide a short and direct response. 3.74e+11. In the year 1999, what is the difference between the Imports (in Local Currency Unit) in Mongolia and Imports (in Local Currency Unit) in Tunisia?
Offer a terse response. 6.60e+11. In the year 2000, what is the difference between the Imports (in Local Currency Unit) of Belize and Imports (in Local Currency Unit) of Canada?
Your answer should be compact. -4.25e+11. In the year 2000, what is the difference between the Imports (in Local Currency Unit) in Belize and Imports (in Local Currency Unit) in Mongolia?
Provide a short and direct response. -8.30e+11. In the year 2000, what is the difference between the Imports (in Local Currency Unit) of Belize and Imports (in Local Currency Unit) of Tunisia?
Your answer should be compact. -1.14e+1. In the year 2000, what is the difference between the Imports (in Local Currency Unit) in Canada and Imports (in Local Currency Unit) in Mongolia?
Offer a very short reply. -4.05e+11. In the year 2000, what is the difference between the Imports (in Local Currency Unit) of Canada and Imports (in Local Currency Unit) of Tunisia?
Offer a very short reply. 4.13e+11. In the year 2000, what is the difference between the Imports (in Local Currency Unit) in Mongolia and Imports (in Local Currency Unit) in Tunisia?
Keep it short and to the point. 8.18e+11. In the year 2001, what is the difference between the Imports (in Local Currency Unit) in Belize and Imports (in Local Currency Unit) in Canada?
Offer a terse response. -4.14e+11. In the year 2001, what is the difference between the Imports (in Local Currency Unit) in Belize and Imports (in Local Currency Unit) in Mongolia?
Ensure brevity in your answer.  -9.10e+11. In the year 2001, what is the difference between the Imports (in Local Currency Unit) in Belize and Imports (in Local Currency Unit) in Tunisia?
Your response must be concise. -1.36e+1. In the year 2001, what is the difference between the Imports (in Local Currency Unit) of Canada and Imports (in Local Currency Unit) of Mongolia?
Offer a very short reply. -4.97e+11. In the year 2001, what is the difference between the Imports (in Local Currency Unit) of Canada and Imports (in Local Currency Unit) of Tunisia?
Offer a terse response. 4.00e+11. In the year 2001, what is the difference between the Imports (in Local Currency Unit) in Mongolia and Imports (in Local Currency Unit) in Tunisia?
Give a very brief answer. 8.97e+11. In the year 2002, what is the difference between the Imports (in Local Currency Unit) of Belize and Imports (in Local Currency Unit) of Canada?
Give a very brief answer. -4.23e+11. In the year 2002, what is the difference between the Imports (in Local Currency Unit) in Belize and Imports (in Local Currency Unit) in Mongolia?
Keep it short and to the point. -1.05e+12. In the year 2002, what is the difference between the Imports (in Local Currency Unit) of Belize and Imports (in Local Currency Unit) of Tunisia?
Provide a succinct answer. -1.34e+1. In the year 2002, what is the difference between the Imports (in Local Currency Unit) in Canada and Imports (in Local Currency Unit) in Mongolia?
Provide a short and direct response. -6.27e+11. In the year 2002, what is the difference between the Imports (in Local Currency Unit) in Canada and Imports (in Local Currency Unit) in Tunisia?
Give a very brief answer. 4.10e+11. In the year 2002, what is the difference between the Imports (in Local Currency Unit) of Mongolia and Imports (in Local Currency Unit) of Tunisia?
Give a very brief answer. 1.04e+12. In the year 2003, what is the difference between the Imports (in Local Currency Unit) of Belize and Imports (in Local Currency Unit) of Canada?
Ensure brevity in your answer.  -4.11e+11. In the year 2003, what is the difference between the Imports (in Local Currency Unit) of Belize and Imports (in Local Currency Unit) of Mongolia?
Give a very brief answer. -1.24e+12. In the year 2003, what is the difference between the Imports (in Local Currency Unit) in Belize and Imports (in Local Currency Unit) in Tunisia?
Your answer should be very brief. -1.39e+1. In the year 2003, what is the difference between the Imports (in Local Currency Unit) of Canada and Imports (in Local Currency Unit) of Mongolia?
Your answer should be compact. -8.30e+11. In the year 2003, what is the difference between the Imports (in Local Currency Unit) of Canada and Imports (in Local Currency Unit) of Tunisia?
Your answer should be very brief. 3.98e+11. In the year 2003, what is the difference between the Imports (in Local Currency Unit) of Mongolia and Imports (in Local Currency Unit) of Tunisia?
Your answer should be compact. 1.23e+12. What is the ratio of the Imports (in Local Currency Unit) in Belize in 1996 to that in 1997?
Your answer should be very brief. 0.88. What is the ratio of the Imports (in Local Currency Unit) in Canada in 1996 to that in 1997?
Your answer should be very brief. 0.87. What is the ratio of the Imports (in Local Currency Unit) in Mongolia in 1996 to that in 1997?
Your answer should be very brief. 0.71. What is the ratio of the Imports (in Local Currency Unit) in Tunisia in 1996 to that in 1997?
Provide a succinct answer. 0.88. What is the ratio of the Imports (in Local Currency Unit) of Belize in 1996 to that in 1998?
Ensure brevity in your answer.  0.82. What is the ratio of the Imports (in Local Currency Unit) of Canada in 1996 to that in 1998?
Offer a very short reply. 0.8. What is the ratio of the Imports (in Local Currency Unit) in Mongolia in 1996 to that in 1998?
Ensure brevity in your answer.  0.56. What is the ratio of the Imports (in Local Currency Unit) of Tunisia in 1996 to that in 1998?
Make the answer very short. 0.81. What is the ratio of the Imports (in Local Currency Unit) in Belize in 1996 to that in 1999?
Offer a very short reply. 0.65. What is the ratio of the Imports (in Local Currency Unit) in Canada in 1996 to that in 1999?
Offer a terse response. 0.74. What is the ratio of the Imports (in Local Currency Unit) in Mongolia in 1996 to that in 1999?
Provide a succinct answer. 0.47. What is the ratio of the Imports (in Local Currency Unit) in Tunisia in 1996 to that in 1999?
Provide a short and direct response. 0.77. What is the ratio of the Imports (in Local Currency Unit) of Belize in 1996 to that in 2000?
Your response must be concise. 0.53. What is the ratio of the Imports (in Local Currency Unit) in Canada in 1996 to that in 2000?
Ensure brevity in your answer.  0.67. What is the ratio of the Imports (in Local Currency Unit) of Mongolia in 1996 to that in 2000?
Your response must be concise. 0.38. What is the ratio of the Imports (in Local Currency Unit) in Tunisia in 1996 to that in 2000?
Provide a short and direct response. 0.66. What is the ratio of the Imports (in Local Currency Unit) of Belize in 1996 to that in 2001?
Give a very brief answer. 0.54. What is the ratio of the Imports (in Local Currency Unit) of Canada in 1996 to that in 2001?
Provide a succinct answer. 0.69. What is the ratio of the Imports (in Local Currency Unit) in Mongolia in 1996 to that in 2001?
Keep it short and to the point. 0.34. What is the ratio of the Imports (in Local Currency Unit) of Tunisia in 1996 to that in 2001?
Make the answer very short. 0.56. What is the ratio of the Imports (in Local Currency Unit) of Belize in 1996 to that in 2002?
Provide a succinct answer. 0.52. What is the ratio of the Imports (in Local Currency Unit) of Canada in 1996 to that in 2002?
Keep it short and to the point. 0.67. What is the ratio of the Imports (in Local Currency Unit) of Mongolia in 1996 to that in 2002?
Provide a succinct answer. 0.3. What is the ratio of the Imports (in Local Currency Unit) of Tunisia in 1996 to that in 2002?
Give a very brief answer. 0.57. What is the ratio of the Imports (in Local Currency Unit) in Belize in 1996 to that in 2003?
Make the answer very short. 0.49. What is the ratio of the Imports (in Local Currency Unit) in Canada in 1996 to that in 2003?
Offer a terse response. 0.69. What is the ratio of the Imports (in Local Currency Unit) in Mongolia in 1996 to that in 2003?
Your answer should be compact. 0.25. What is the ratio of the Imports (in Local Currency Unit) of Tunisia in 1996 to that in 2003?
Your answer should be very brief. 0.55. What is the ratio of the Imports (in Local Currency Unit) of Belize in 1997 to that in 1998?
Provide a short and direct response. 0.93. What is the ratio of the Imports (in Local Currency Unit) in Canada in 1997 to that in 1998?
Give a very brief answer. 0.92. What is the ratio of the Imports (in Local Currency Unit) in Mongolia in 1997 to that in 1998?
Your response must be concise. 0.78. What is the ratio of the Imports (in Local Currency Unit) in Tunisia in 1997 to that in 1998?
Ensure brevity in your answer.  0.92. What is the ratio of the Imports (in Local Currency Unit) in Belize in 1997 to that in 1999?
Provide a succinct answer. 0.74. What is the ratio of the Imports (in Local Currency Unit) of Canada in 1997 to that in 1999?
Keep it short and to the point. 0.85. What is the ratio of the Imports (in Local Currency Unit) in Mongolia in 1997 to that in 1999?
Give a very brief answer. 0.66. What is the ratio of the Imports (in Local Currency Unit) in Tunisia in 1997 to that in 1999?
Give a very brief answer. 0.87. What is the ratio of the Imports (in Local Currency Unit) of Belize in 1997 to that in 2000?
Provide a short and direct response. 0.59. What is the ratio of the Imports (in Local Currency Unit) in Canada in 1997 to that in 2000?
Provide a succinct answer. 0.77. What is the ratio of the Imports (in Local Currency Unit) of Mongolia in 1997 to that in 2000?
Provide a short and direct response. 0.53. What is the ratio of the Imports (in Local Currency Unit) in Tunisia in 1997 to that in 2000?
Your answer should be compact. 0.75. What is the ratio of the Imports (in Local Currency Unit) in Belize in 1997 to that in 2001?
Ensure brevity in your answer.  0.6. What is the ratio of the Imports (in Local Currency Unit) of Canada in 1997 to that in 2001?
Ensure brevity in your answer.  0.79. What is the ratio of the Imports (in Local Currency Unit) in Mongolia in 1997 to that in 2001?
Your answer should be very brief. 0.48. What is the ratio of the Imports (in Local Currency Unit) of Tunisia in 1997 to that in 2001?
Offer a terse response. 0.64. What is the ratio of the Imports (in Local Currency Unit) in Belize in 1997 to that in 2002?
Your response must be concise. 0.59. What is the ratio of the Imports (in Local Currency Unit) in Canada in 1997 to that in 2002?
Your response must be concise. 0.77. What is the ratio of the Imports (in Local Currency Unit) of Mongolia in 1997 to that in 2002?
Your answer should be very brief. 0.42. What is the ratio of the Imports (in Local Currency Unit) of Tunisia in 1997 to that in 2002?
Your answer should be compact. 0.65. What is the ratio of the Imports (in Local Currency Unit) in Belize in 1997 to that in 2003?
Make the answer very short. 0.56. What is the ratio of the Imports (in Local Currency Unit) of Canada in 1997 to that in 2003?
Keep it short and to the point. 0.79. What is the ratio of the Imports (in Local Currency Unit) in Mongolia in 1997 to that in 2003?
Make the answer very short. 0.36. What is the ratio of the Imports (in Local Currency Unit) in Tunisia in 1997 to that in 2003?
Provide a succinct answer. 0.63. What is the ratio of the Imports (in Local Currency Unit) in Belize in 1998 to that in 1999?
Ensure brevity in your answer.  0.79. What is the ratio of the Imports (in Local Currency Unit) of Canada in 1998 to that in 1999?
Ensure brevity in your answer.  0.93. What is the ratio of the Imports (in Local Currency Unit) in Mongolia in 1998 to that in 1999?
Provide a short and direct response. 0.84. What is the ratio of the Imports (in Local Currency Unit) of Tunisia in 1998 to that in 1999?
Offer a very short reply. 0.95. What is the ratio of the Imports (in Local Currency Unit) of Belize in 1998 to that in 2000?
Ensure brevity in your answer.  0.64. What is the ratio of the Imports (in Local Currency Unit) in Canada in 1998 to that in 2000?
Offer a very short reply. 0.84. What is the ratio of the Imports (in Local Currency Unit) of Mongolia in 1998 to that in 2000?
Give a very brief answer. 0.68. What is the ratio of the Imports (in Local Currency Unit) in Tunisia in 1998 to that in 2000?
Your answer should be very brief. 0.81. What is the ratio of the Imports (in Local Currency Unit) of Belize in 1998 to that in 2001?
Your response must be concise. 0.65. What is the ratio of the Imports (in Local Currency Unit) of Canada in 1998 to that in 2001?
Your answer should be very brief. 0.86. What is the ratio of the Imports (in Local Currency Unit) of Mongolia in 1998 to that in 2001?
Provide a succinct answer. 0.62. What is the ratio of the Imports (in Local Currency Unit) of Tunisia in 1998 to that in 2001?
Offer a terse response. 0.69. What is the ratio of the Imports (in Local Currency Unit) in Belize in 1998 to that in 2002?
Your answer should be compact. 0.64. What is the ratio of the Imports (in Local Currency Unit) of Canada in 1998 to that in 2002?
Your response must be concise. 0.84. What is the ratio of the Imports (in Local Currency Unit) in Mongolia in 1998 to that in 2002?
Make the answer very short. 0.54. What is the ratio of the Imports (in Local Currency Unit) of Tunisia in 1998 to that in 2002?
Your answer should be very brief. 0.7. What is the ratio of the Imports (in Local Currency Unit) of Belize in 1998 to that in 2003?
Provide a succinct answer. 0.6. What is the ratio of the Imports (in Local Currency Unit) of Canada in 1998 to that in 2003?
Offer a terse response. 0.87. What is the ratio of the Imports (in Local Currency Unit) in Mongolia in 1998 to that in 2003?
Make the answer very short. 0.45. What is the ratio of the Imports (in Local Currency Unit) in Tunisia in 1998 to that in 2003?
Provide a succinct answer. 0.68. What is the ratio of the Imports (in Local Currency Unit) of Belize in 1999 to that in 2000?
Make the answer very short. 0.81. What is the ratio of the Imports (in Local Currency Unit) of Canada in 1999 to that in 2000?
Provide a succinct answer. 0.9. What is the ratio of the Imports (in Local Currency Unit) of Mongolia in 1999 to that in 2000?
Give a very brief answer. 0.81. What is the ratio of the Imports (in Local Currency Unit) in Tunisia in 1999 to that in 2000?
Keep it short and to the point. 0.86. What is the ratio of the Imports (in Local Currency Unit) of Belize in 1999 to that in 2001?
Your answer should be compact. 0.82. What is the ratio of the Imports (in Local Currency Unit) of Canada in 1999 to that in 2001?
Your response must be concise. 0.93. What is the ratio of the Imports (in Local Currency Unit) of Mongolia in 1999 to that in 2001?
Give a very brief answer. 0.74. What is the ratio of the Imports (in Local Currency Unit) of Tunisia in 1999 to that in 2001?
Keep it short and to the point. 0.73. What is the ratio of the Imports (in Local Currency Unit) of Belize in 1999 to that in 2002?
Keep it short and to the point. 0.8. What is the ratio of the Imports (in Local Currency Unit) in Canada in 1999 to that in 2002?
Your answer should be very brief. 0.91. What is the ratio of the Imports (in Local Currency Unit) in Mongolia in 1999 to that in 2002?
Your response must be concise. 0.64. What is the ratio of the Imports (in Local Currency Unit) of Tunisia in 1999 to that in 2002?
Offer a terse response. 0.74. What is the ratio of the Imports (in Local Currency Unit) of Belize in 1999 to that in 2003?
Keep it short and to the point. 0.76. What is the ratio of the Imports (in Local Currency Unit) in Canada in 1999 to that in 2003?
Provide a succinct answer. 0.93. What is the ratio of the Imports (in Local Currency Unit) of Mongolia in 1999 to that in 2003?
Your answer should be compact. 0.54. What is the ratio of the Imports (in Local Currency Unit) in Tunisia in 1999 to that in 2003?
Ensure brevity in your answer.  0.72. What is the ratio of the Imports (in Local Currency Unit) in Belize in 2000 to that in 2001?
Your answer should be very brief. 1.02. What is the ratio of the Imports (in Local Currency Unit) of Canada in 2000 to that in 2001?
Offer a terse response. 1.03. What is the ratio of the Imports (in Local Currency Unit) of Mongolia in 2000 to that in 2001?
Offer a terse response. 0.91. What is the ratio of the Imports (in Local Currency Unit) in Tunisia in 2000 to that in 2001?
Make the answer very short. 0.85. What is the ratio of the Imports (in Local Currency Unit) of Mongolia in 2000 to that in 2002?
Keep it short and to the point. 0.79. What is the ratio of the Imports (in Local Currency Unit) in Tunisia in 2000 to that in 2002?
Your answer should be compact. 0.86. What is the ratio of the Imports (in Local Currency Unit) in Belize in 2000 to that in 2003?
Give a very brief answer. 0.94. What is the ratio of the Imports (in Local Currency Unit) in Canada in 2000 to that in 2003?
Offer a very short reply. 1.03. What is the ratio of the Imports (in Local Currency Unit) of Mongolia in 2000 to that in 2003?
Your response must be concise. 0.67. What is the ratio of the Imports (in Local Currency Unit) of Tunisia in 2000 to that in 2003?
Offer a terse response. 0.83. What is the ratio of the Imports (in Local Currency Unit) of Belize in 2001 to that in 2002?
Ensure brevity in your answer.  0.98. What is the ratio of the Imports (in Local Currency Unit) of Canada in 2001 to that in 2002?
Your answer should be compact. 0.98. What is the ratio of the Imports (in Local Currency Unit) in Mongolia in 2001 to that in 2002?
Your response must be concise. 0.87. What is the ratio of the Imports (in Local Currency Unit) in Tunisia in 2001 to that in 2002?
Your answer should be very brief. 1.01. What is the ratio of the Imports (in Local Currency Unit) in Belize in 2001 to that in 2003?
Your answer should be very brief. 0.92. What is the ratio of the Imports (in Local Currency Unit) of Canada in 2001 to that in 2003?
Make the answer very short. 1. What is the ratio of the Imports (in Local Currency Unit) in Mongolia in 2001 to that in 2003?
Keep it short and to the point. 0.73. What is the ratio of the Imports (in Local Currency Unit) in Tunisia in 2001 to that in 2003?
Provide a succinct answer. 0.98. What is the ratio of the Imports (in Local Currency Unit) of Canada in 2002 to that in 2003?
Provide a short and direct response. 1.03. What is the ratio of the Imports (in Local Currency Unit) of Mongolia in 2002 to that in 2003?
Provide a succinct answer. 0.85. What is the ratio of the Imports (in Local Currency Unit) in Tunisia in 2002 to that in 2003?
Give a very brief answer. 0.97. What is the difference between the highest and the second highest Imports (in Local Currency Unit) in Belize?
Your answer should be very brief. 7.26e+07. What is the difference between the highest and the second highest Imports (in Local Currency Unit) in Canada?
Provide a short and direct response. 1.13e+09. What is the difference between the highest and the second highest Imports (in Local Currency Unit) of Mongolia?
Give a very brief answer. 1.92e+11. What is the difference between the highest and the second highest Imports (in Local Currency Unit) of Tunisia?
Your response must be concise. 3.41e+08. What is the difference between the highest and the lowest Imports (in Local Currency Unit) of Belize?
Your response must be concise. 6.61e+08. What is the difference between the highest and the lowest Imports (in Local Currency Unit) of Canada?
Make the answer very short. 1.41e+11. What is the difference between the highest and the lowest Imports (in Local Currency Unit) in Mongolia?
Give a very brief answer. 9.30e+11. What is the difference between the highest and the lowest Imports (in Local Currency Unit) in Tunisia?
Keep it short and to the point. 6.86e+09. 